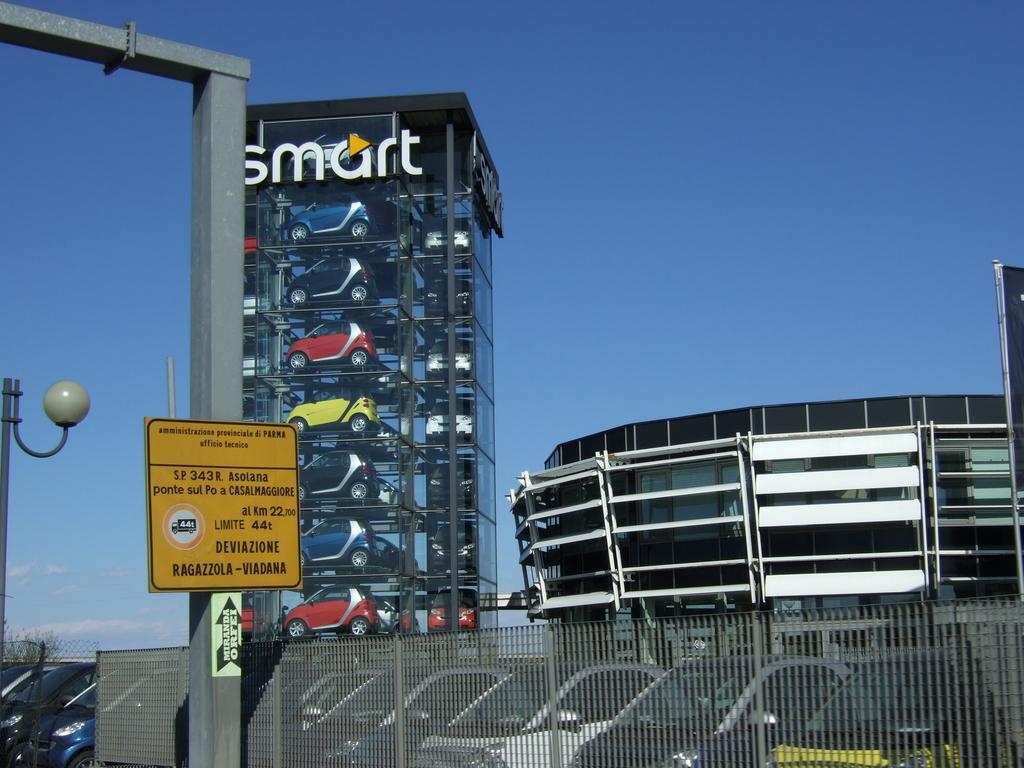What is the main object in the image? There is a name board in the image. What other structures can be seen in the image? There are poles, a fence, vehicles, and buildings visible in the image. What is the background of the image? The sky is visible in the background of the image. Can you tell me the temperature of the hot receipt in the image? There is no receipt, hot or otherwise, present in the image. 